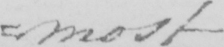Can you read and transcribe this handwriting? =most 